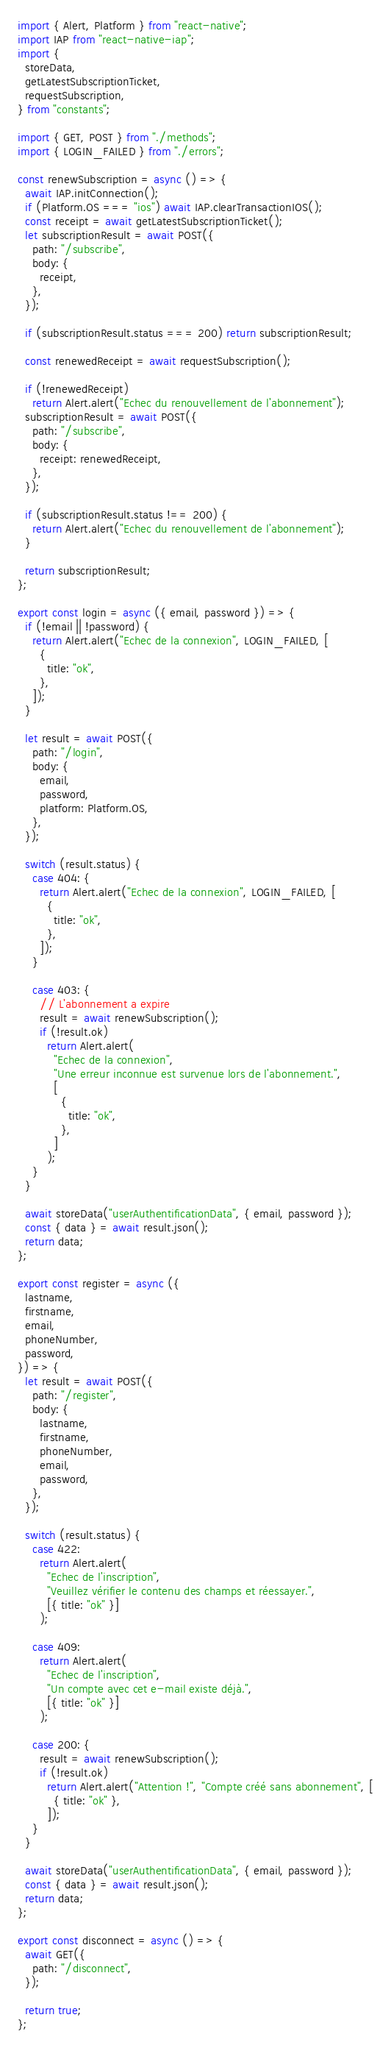Convert code to text. <code><loc_0><loc_0><loc_500><loc_500><_JavaScript_>import { Alert, Platform } from "react-native";
import IAP from "react-native-iap";
import {
  storeData,
  getLatestSubscriptionTicket,
  requestSubscription,
} from "constants";

import { GET, POST } from "./methods";
import { LOGIN_FAILED } from "./errors";

const renewSubscription = async () => {
  await IAP.initConnection();
  if (Platform.OS === "ios") await IAP.clearTransactionIOS();
  const receipt = await getLatestSubscriptionTicket();
  let subscriptionResult = await POST({
    path: "/subscribe",
    body: {
      receipt,
    },
  });

  if (subscriptionResult.status === 200) return subscriptionResult;

  const renewedReceipt = await requestSubscription();

  if (!renewedReceipt)
    return Alert.alert("Echec du renouvellement de l'abonnement");
  subscriptionResult = await POST({
    path: "/subscribe",
    body: {
      receipt: renewedReceipt,
    },
  });

  if (subscriptionResult.status !== 200) {
    return Alert.alert("Echec du renouvellement de l'abonnement");
  }

  return subscriptionResult;
};

export const login = async ({ email, password }) => {
  if (!email || !password) {
    return Alert.alert("Echec de la connexion", LOGIN_FAILED, [
      {
        title: "ok",
      },
    ]);
  }

  let result = await POST({
    path: "/login",
    body: {
      email,
      password,
      platform: Platform.OS,
    },
  });

  switch (result.status) {
    case 404: {
      return Alert.alert("Echec de la connexion", LOGIN_FAILED, [
        {
          title: "ok",
        },
      ]);
    }

    case 403: {
      // L'abonnement a expire
      result = await renewSubscription();
      if (!result.ok)
        return Alert.alert(
          "Echec de la connexion",
          "Une erreur inconnue est survenue lors de l'abonnement.",
          [
            {
              title: "ok",
            },
          ]
        );
    }
  }

  await storeData("userAuthentificationData", { email, password });
  const { data } = await result.json();
  return data;
};

export const register = async ({
  lastname,
  firstname,
  email,
  phoneNumber,
  password,
}) => {
  let result = await POST({
    path: "/register",
    body: {
      lastname,
      firstname,
      phoneNumber,
      email,
      password,
    },
  });

  switch (result.status) {
    case 422:
      return Alert.alert(
        "Echec de l'inscription",
        "Veuillez vérifier le contenu des champs et réessayer.",
        [{ title: "ok" }]
      );

    case 409:
      return Alert.alert(
        "Echec de l'inscription",
        "Un compte avec cet e-mail existe déjà.",
        [{ title: "ok" }]
      );

    case 200: {
      result = await renewSubscription();
      if (!result.ok)
        return Alert.alert("Attention !", "Compte créé sans abonnement", [
          { title: "ok" },
        ]);
    }
  }

  await storeData("userAuthentificationData", { email, password });
  const { data } = await result.json();
  return data;
};

export const disconnect = async () => {
  await GET({
    path: "/disconnect",
  });

  return true;
};
</code> 